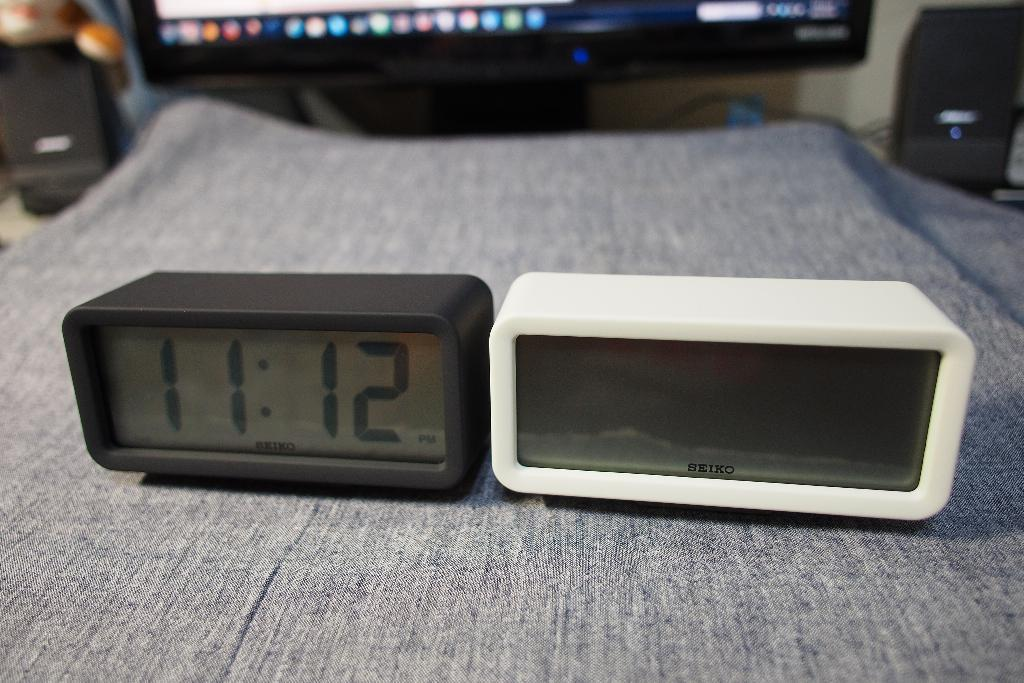<image>
Describe the image concisely. A white and a black Seiko digital clock. 